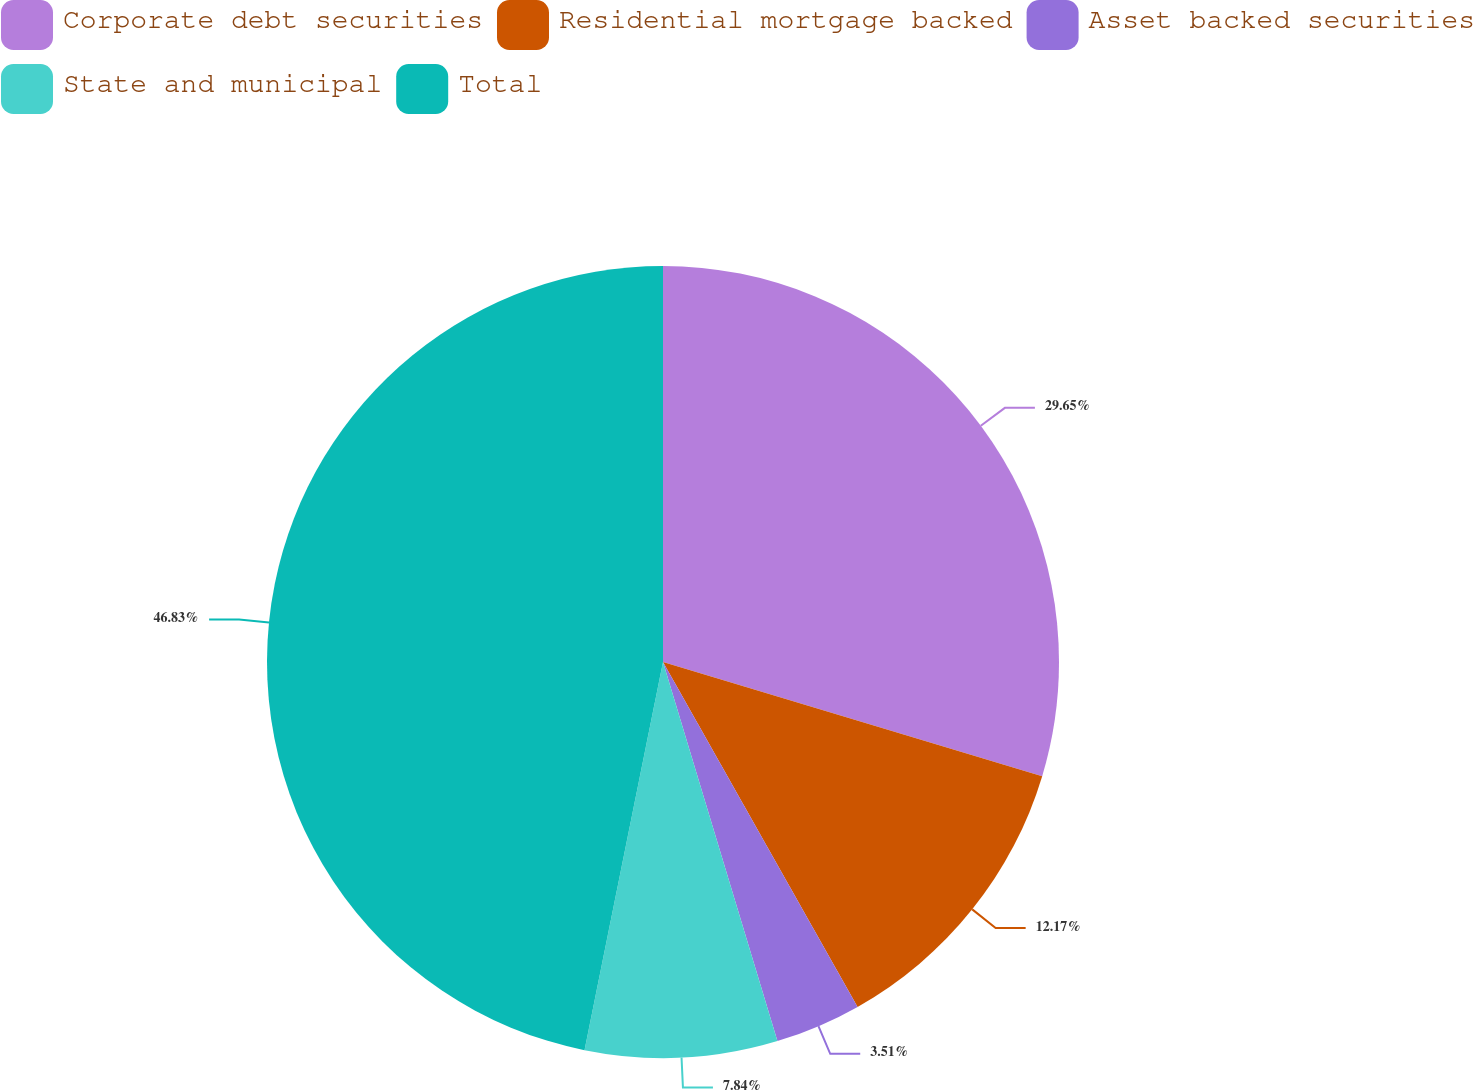Convert chart. <chart><loc_0><loc_0><loc_500><loc_500><pie_chart><fcel>Corporate debt securities<fcel>Residential mortgage backed<fcel>Asset backed securities<fcel>State and municipal<fcel>Total<nl><fcel>29.65%<fcel>12.17%<fcel>3.51%<fcel>7.84%<fcel>46.82%<nl></chart> 